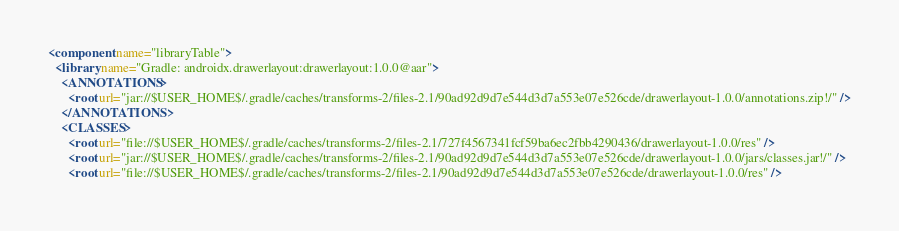Convert code to text. <code><loc_0><loc_0><loc_500><loc_500><_XML_><component name="libraryTable">
  <library name="Gradle: androidx.drawerlayout:drawerlayout:1.0.0@aar">
    <ANNOTATIONS>
      <root url="jar://$USER_HOME$/.gradle/caches/transforms-2/files-2.1/90ad92d9d7e544d3d7a553e07e526cde/drawerlayout-1.0.0/annotations.zip!/" />
    </ANNOTATIONS>
    <CLASSES>
      <root url="file://$USER_HOME$/.gradle/caches/transforms-2/files-2.1/727f4567341fcf59ba6ec2fbb4290436/drawerlayout-1.0.0/res" />
      <root url="jar://$USER_HOME$/.gradle/caches/transforms-2/files-2.1/90ad92d9d7e544d3d7a553e07e526cde/drawerlayout-1.0.0/jars/classes.jar!/" />
      <root url="file://$USER_HOME$/.gradle/caches/transforms-2/files-2.1/90ad92d9d7e544d3d7a553e07e526cde/drawerlayout-1.0.0/res" /></code> 